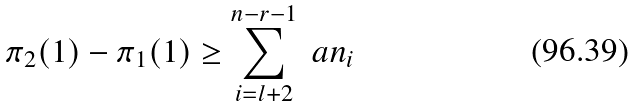<formula> <loc_0><loc_0><loc_500><loc_500>\pi _ { 2 } ( 1 ) - \pi _ { 1 } ( 1 ) \geq \sum _ { i = l + 2 } ^ { n - r - 1 } \ a n _ { i }</formula> 